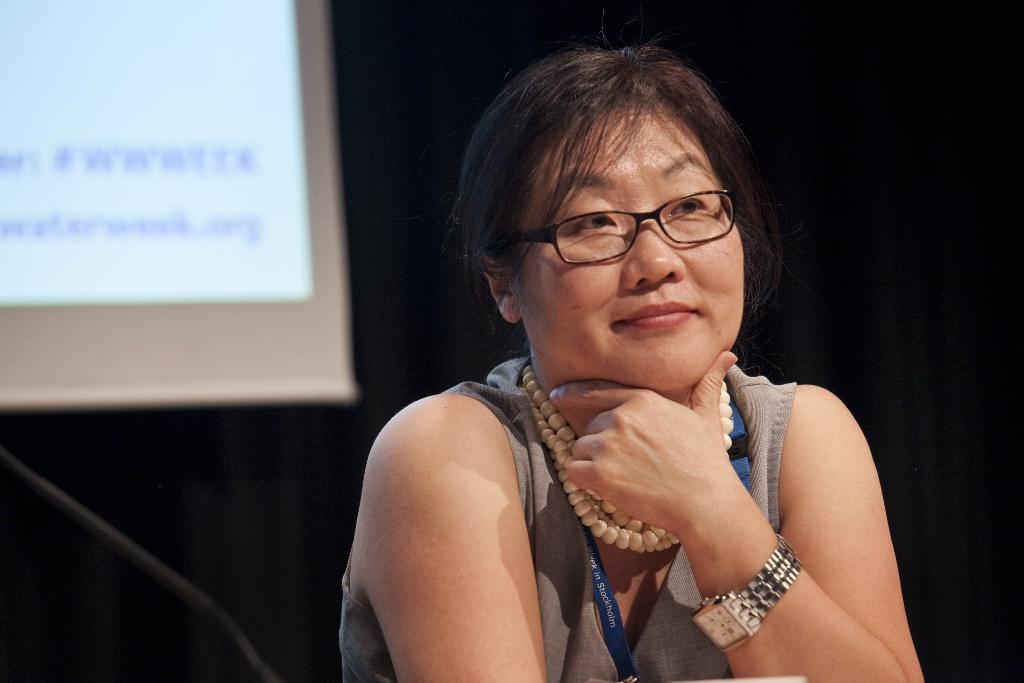Can you describe this image briefly? In this image there is one women in the bottom of this image is wearing some necklace and a watch. There is a black color curtain in the background. There is a white color screen on the left side of this image. 